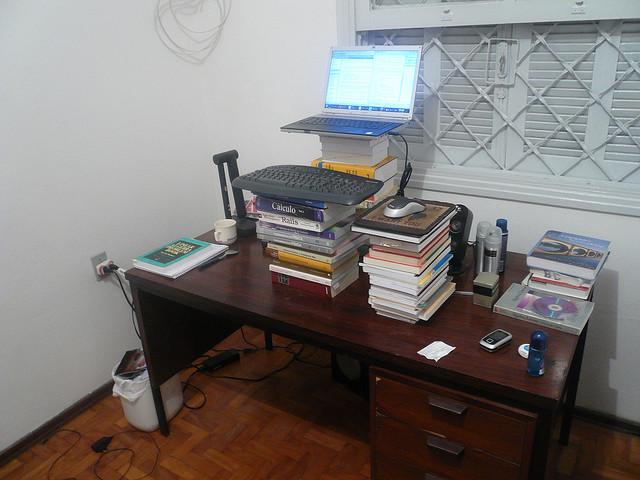Should this desk be cleaned with Windex or Pledge?
Quick response, please. Pledge. Is there anything unusual about the objects on the desk?
Answer briefly. Yes. Where is the computer mouse?
Answer briefly. On books. Are there any boxes next to the desk?
Answer briefly. No. 